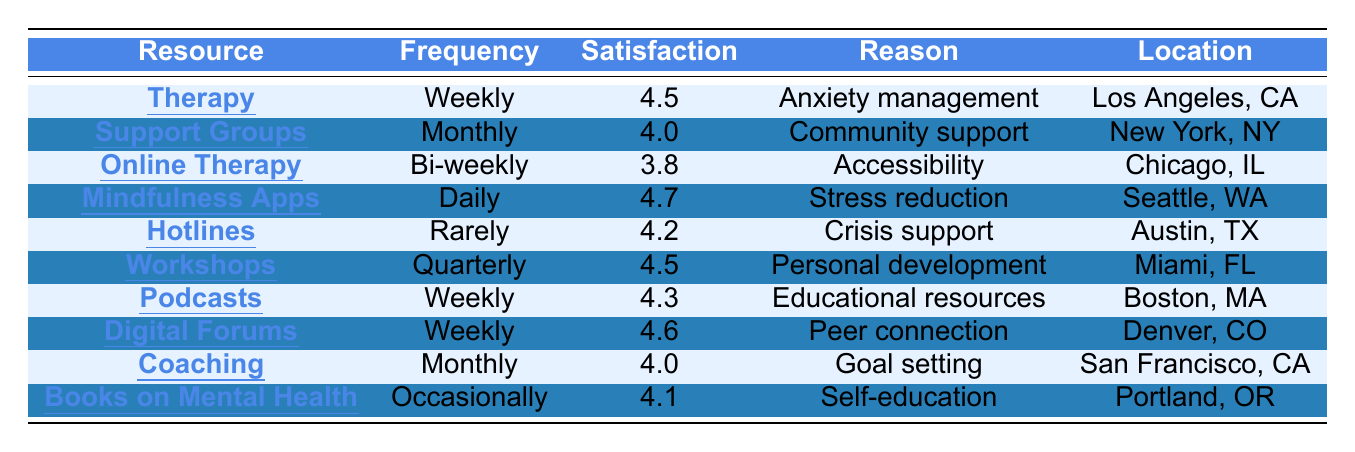What is the highest satisfaction rating among the mental health resources used? The table lists the satisfaction ratings for each resource used. The ratings are 4.5, 4.0, 3.8, 4.7, 4.2, 4.5, 4.3, 4.6, 4.0, and 4.1. The highest of these ratings is 4.7.
Answer: 4.7 How often is "Mindfulness Apps" used according to the survey? The table indicates that "Mindfulness Apps" are used daily.
Answer: Daily Which mental health resource is used the least frequently? Looking at the frequency of use, "Hotlines" are listed as used rarely, indicating it is the least frequent resource among those represented in the table.
Answer: Hotlines What is the average satisfaction rating of all the resources listed in the survey? To find the average, we sum the satisfaction ratings: 4.5 + 4.0 + 3.8 + 4.7 + 4.2 + 4.5 + 4.3 + 4.6 + 4.0 + 4.1 = 44.7. There are 10 responses, so the average satisfaction rating is 44.7 / 10 = 4.47.
Answer: 4.47 Is there any mental health resource that has a frequency of use listed as "Occasionally"? The table shows that "Books on Mental Health" has a frequency of use listed as "Occasionally", confirming that such a resource exists in the survey data.
Answer: Yes Which resources are used weekly and have a satisfaction rating greater than 4.4? The resources that are used weekly in the table include "Therapy" (4.5), "Podcasts" (4.3), and "Digital Forums" (4.6). Out of these, "Therapy" and "Digital Forums" have satisfaction ratings that are greater than 4.4.
Answer: Therapy and Digital Forums What is the total number of respondents who used online resources? The online resources listed in the table are "Online Therapy", "Mindfulness Apps", "Podcasts", and "Digital Forums", which correspond to RespondentID 3, 4, 7, and 8. Thus, there are 4 respondents who used online resources.
Answer: 4 How many respondents used resources for personal development? From the table, the only resource explicitly labeled for personal development is "Workshops", which is used by 1 respondent (RespondentID 6).
Answer: 1 Is there a gender that does not use "Hotlines"? Referring to the table, "Hotlines" are used by one male respondent, so there is no data indicating that another gender used them. Therefore, females and non-binary respondents are not represented as users of this resource in the survey.
Answer: Yes What reason was given most frequently for using resources? By analyzing the reasons listed, "Anxiety management" (Therapy), "Community support" (Support Groups), "Accessibility" (Online Therapy), "Stress reduction" (Mindfulness Apps), "Crisis support" (Hotlines), and unique reasons for Workshops, Podcasts, Digital Forums, Coaching, and Books, each appears once. Thus, all unique reasons are used equally, with no one reason predominating.
Answer: None (all reasons used once) 